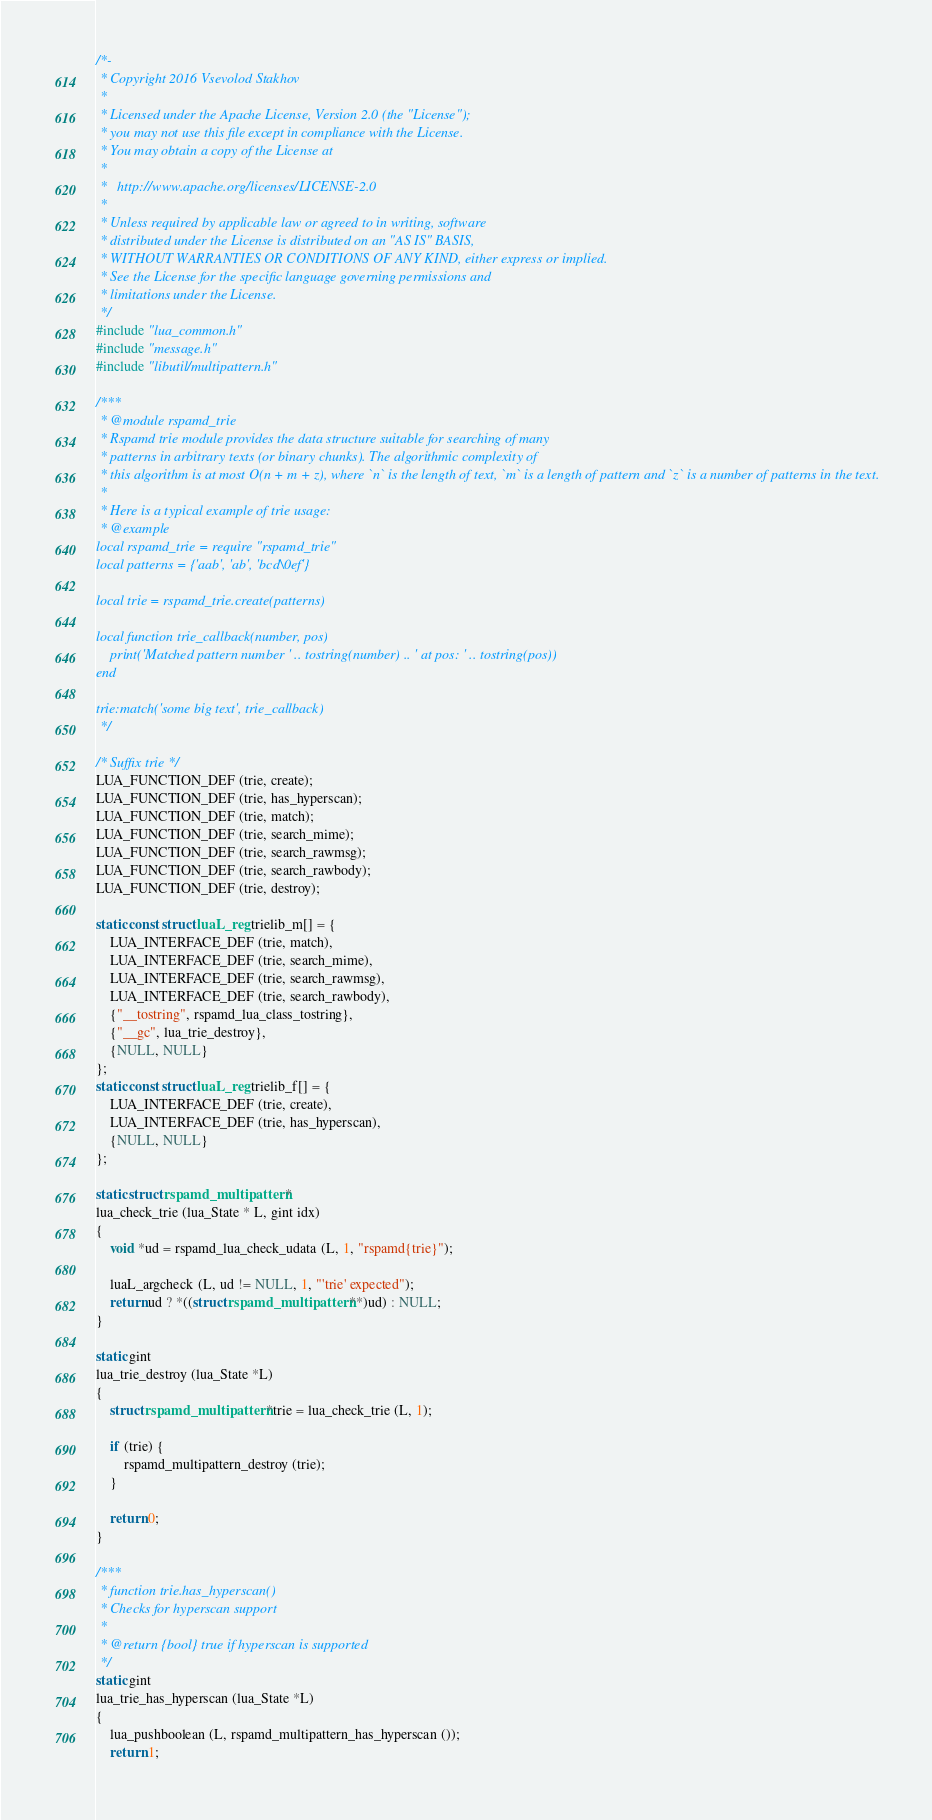Convert code to text. <code><loc_0><loc_0><loc_500><loc_500><_C_>/*-
 * Copyright 2016 Vsevolod Stakhov
 *
 * Licensed under the Apache License, Version 2.0 (the "License");
 * you may not use this file except in compliance with the License.
 * You may obtain a copy of the License at
 *
 *   http://www.apache.org/licenses/LICENSE-2.0
 *
 * Unless required by applicable law or agreed to in writing, software
 * distributed under the License is distributed on an "AS IS" BASIS,
 * WITHOUT WARRANTIES OR CONDITIONS OF ANY KIND, either express or implied.
 * See the License for the specific language governing permissions and
 * limitations under the License.
 */
#include "lua_common.h"
#include "message.h"
#include "libutil/multipattern.h"

/***
 * @module rspamd_trie
 * Rspamd trie module provides the data structure suitable for searching of many
 * patterns in arbitrary texts (or binary chunks). The algorithmic complexity of
 * this algorithm is at most O(n + m + z), where `n` is the length of text, `m` is a length of pattern and `z` is a number of patterns in the text.
 *
 * Here is a typical example of trie usage:
 * @example
local rspamd_trie = require "rspamd_trie"
local patterns = {'aab', 'ab', 'bcd\0ef'}

local trie = rspamd_trie.create(patterns)

local function trie_callback(number, pos)
	print('Matched pattern number ' .. tostring(number) .. ' at pos: ' .. tostring(pos))
end

trie:match('some big text', trie_callback)
 */

/* Suffix trie */
LUA_FUNCTION_DEF (trie, create);
LUA_FUNCTION_DEF (trie, has_hyperscan);
LUA_FUNCTION_DEF (trie, match);
LUA_FUNCTION_DEF (trie, search_mime);
LUA_FUNCTION_DEF (trie, search_rawmsg);
LUA_FUNCTION_DEF (trie, search_rawbody);
LUA_FUNCTION_DEF (trie, destroy);

static const struct luaL_reg trielib_m[] = {
	LUA_INTERFACE_DEF (trie, match),
	LUA_INTERFACE_DEF (trie, search_mime),
	LUA_INTERFACE_DEF (trie, search_rawmsg),
	LUA_INTERFACE_DEF (trie, search_rawbody),
	{"__tostring", rspamd_lua_class_tostring},
	{"__gc", lua_trie_destroy},
	{NULL, NULL}
};
static const struct luaL_reg trielib_f[] = {
	LUA_INTERFACE_DEF (trie, create),
	LUA_INTERFACE_DEF (trie, has_hyperscan),
	{NULL, NULL}
};

static struct rspamd_multipattern *
lua_check_trie (lua_State * L, gint idx)
{
	void *ud = rspamd_lua_check_udata (L, 1, "rspamd{trie}");

	luaL_argcheck (L, ud != NULL, 1, "'trie' expected");
	return ud ? *((struct rspamd_multipattern **)ud) : NULL;
}

static gint
lua_trie_destroy (lua_State *L)
{
	struct rspamd_multipattern *trie = lua_check_trie (L, 1);

	if (trie) {
		rspamd_multipattern_destroy (trie);
	}

	return 0;
}

/***
 * function trie.has_hyperscan()
 * Checks for hyperscan support
 *
 * @return {bool} true if hyperscan is supported
 */
static gint
lua_trie_has_hyperscan (lua_State *L)
{
	lua_pushboolean (L, rspamd_multipattern_has_hyperscan ());
	return 1;</code> 